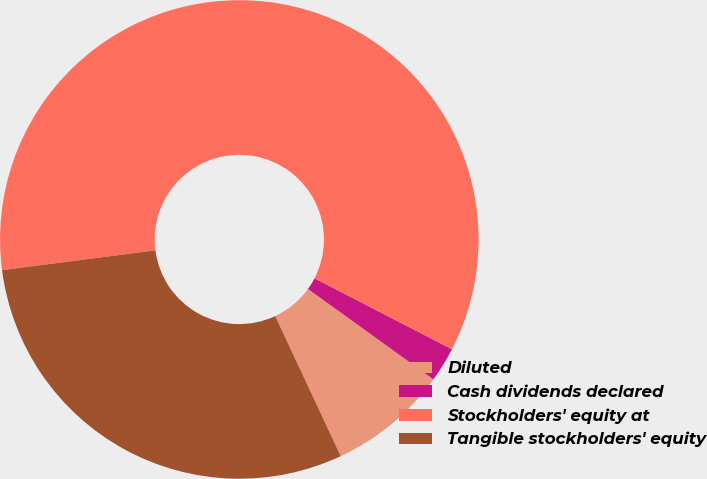Convert chart to OTSL. <chart><loc_0><loc_0><loc_500><loc_500><pie_chart><fcel>Diluted<fcel>Cash dividends declared<fcel>Stockholders' equity at<fcel>Tangible stockholders' equity<nl><fcel>8.09%<fcel>2.36%<fcel>59.64%<fcel>29.92%<nl></chart> 